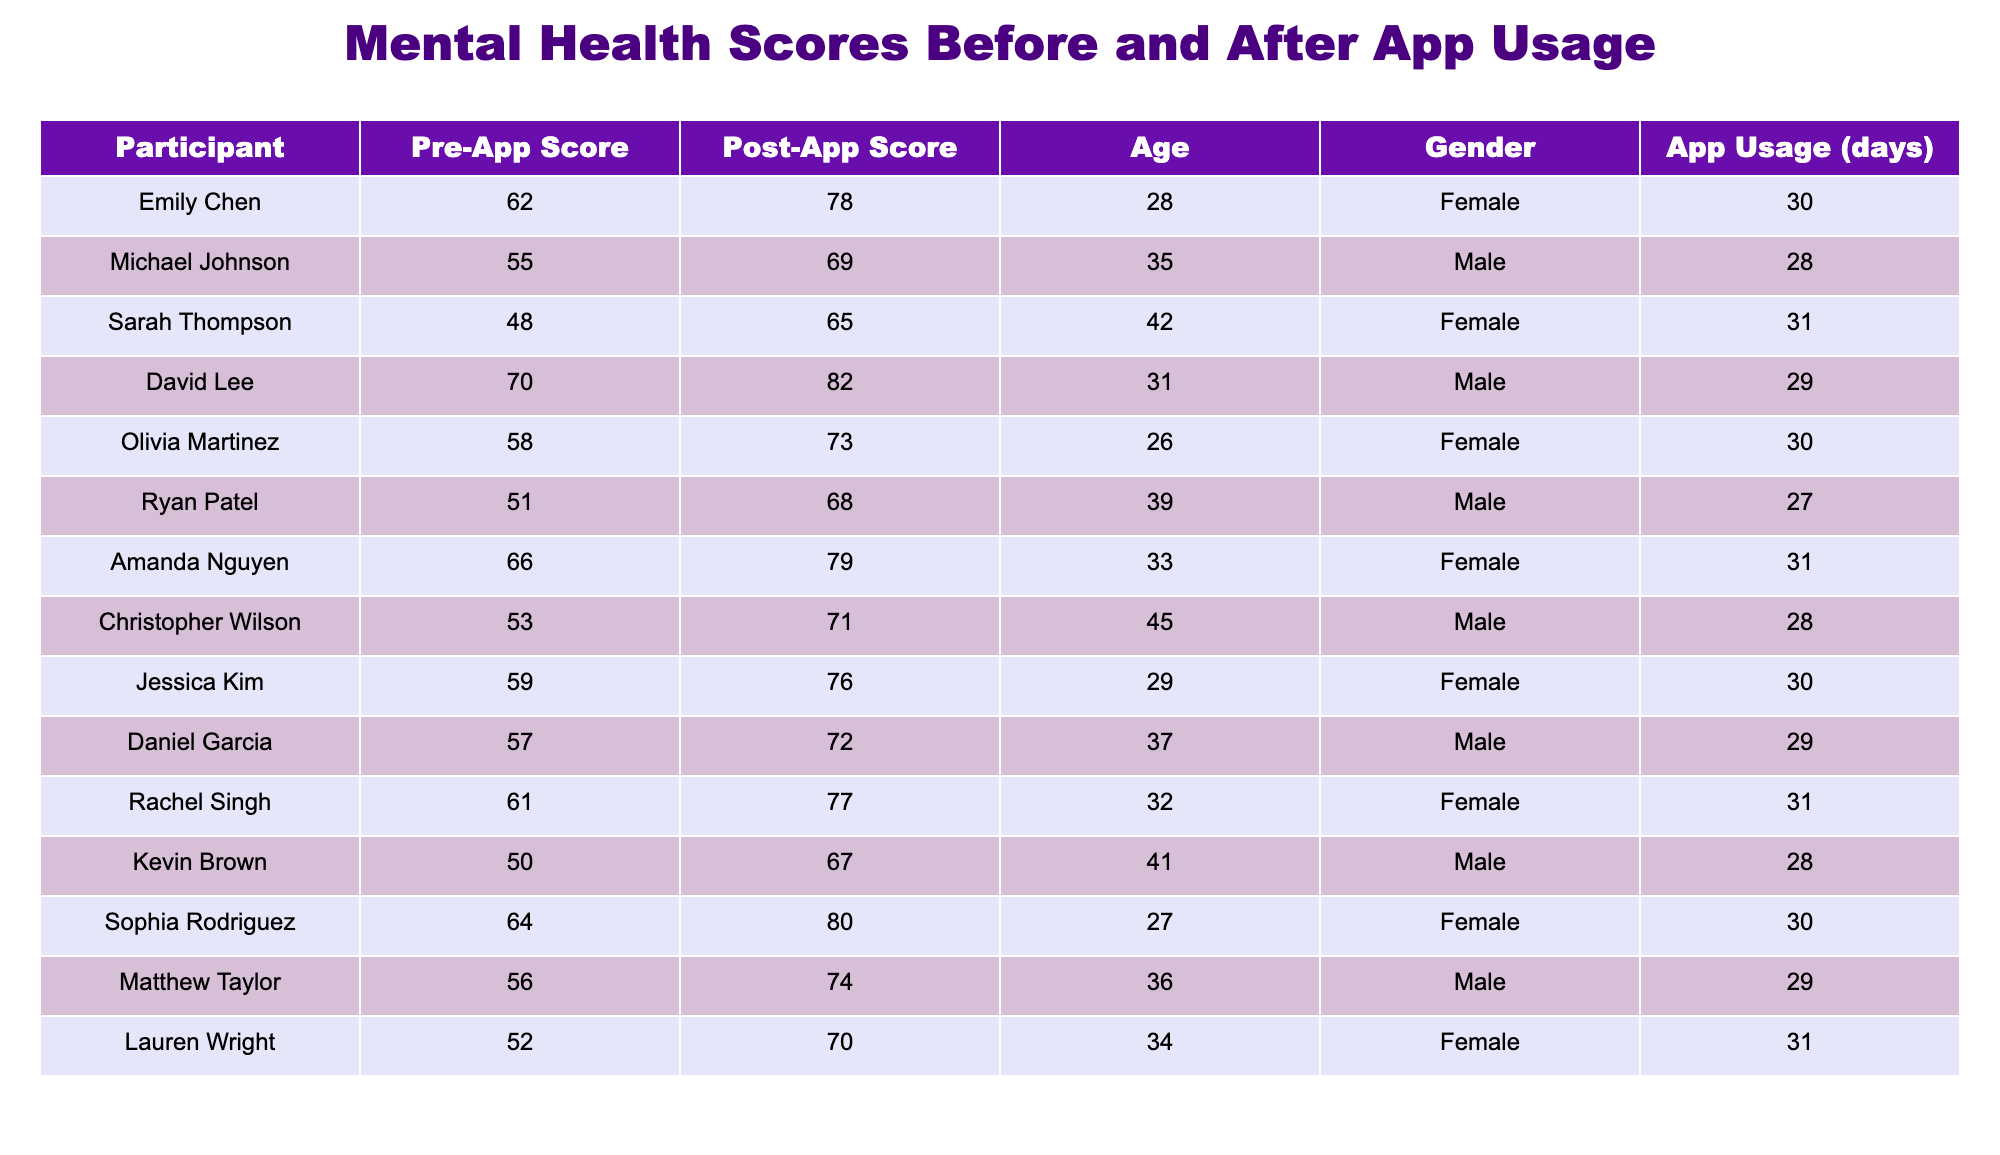What was Emily Chen's pre-app score? Referring to the table, Emily Chen's pre-app score is listed directly under the "Pre-App Score" column. The value corresponding to her is 62.
Answer: 62 What is the gender of the participant with the highest post-app score? The highest post-app score is 82, which belongs to David Lee. Looking at the "Gender" column for David Lee, his gender is Male.
Answer: Male What is the average improvement in mental health scores among all participants? First, we calculate the improvement for each participant, which is the post-app score minus the pre-app score. The improvements are: 16, 14, 17, 12, 15, 17, 13, 18, 17, 15, 16, 17, 16, 18, and 18. Adding these improvements gives 225. There are 15 participants, so the average improvement is 225/15 = 15.
Answer: 15 Did any participant's post-app score decrease after using the application? We check the post-app scores for all participants and compare them with their pre-app scores. Each participant has a post-app score that is higher than their pre-app score. Therefore, no participant saw a decrease in their scores.
Answer: No Which age group (under 30, 30-40, over 40) has the highest average post-app score? We categorize participants based on their ages. 
- Under 30: Emily (78), Olivia (73), Sophia (80) → Average = (78 + 73 + 80)/3 = 77 
- Age 30-40: Michael (69), David (82), Ryan (68), Amanda (79), Christopher (71), Daniel (72), Kevin (67), Matthew (74) → Average = (69 + 82 + 68 + 79 + 71 + 72 + 67 + 74)/8 = 72.875 
- Over 40: Sarah (65), Rachel (77), Lauren (70) → Average = (65 + 77 + 70)/3 = 70.67 
The highest average is found in the under 30 age group with an average post-app score of 77.
Answer: Under 30 How many days did Sarah Thompson use the app? Referring to the "App Usage (days)" column, Sarah Thompson's entry shows that she used the app for 31 days.
Answer: 31 What is the difference in pre-app scores between the oldest and youngest participants? The oldest participant is Christopher Wilson, who is 45 with a pre-app score of 53, and the youngest participant is Olivia Martinez, who is 26 with a pre-app score of 58. The difference is calculated by subtracting the younger participant's score from the older participant's score: 58 - 53 = 5.
Answer: 5 What percentage of participants were female? There are 15 participants total and 8 females listed in the "Gender" column. The percentage is calculated as (8/15) * 100 = 53.33%.
Answer: 53.33% 